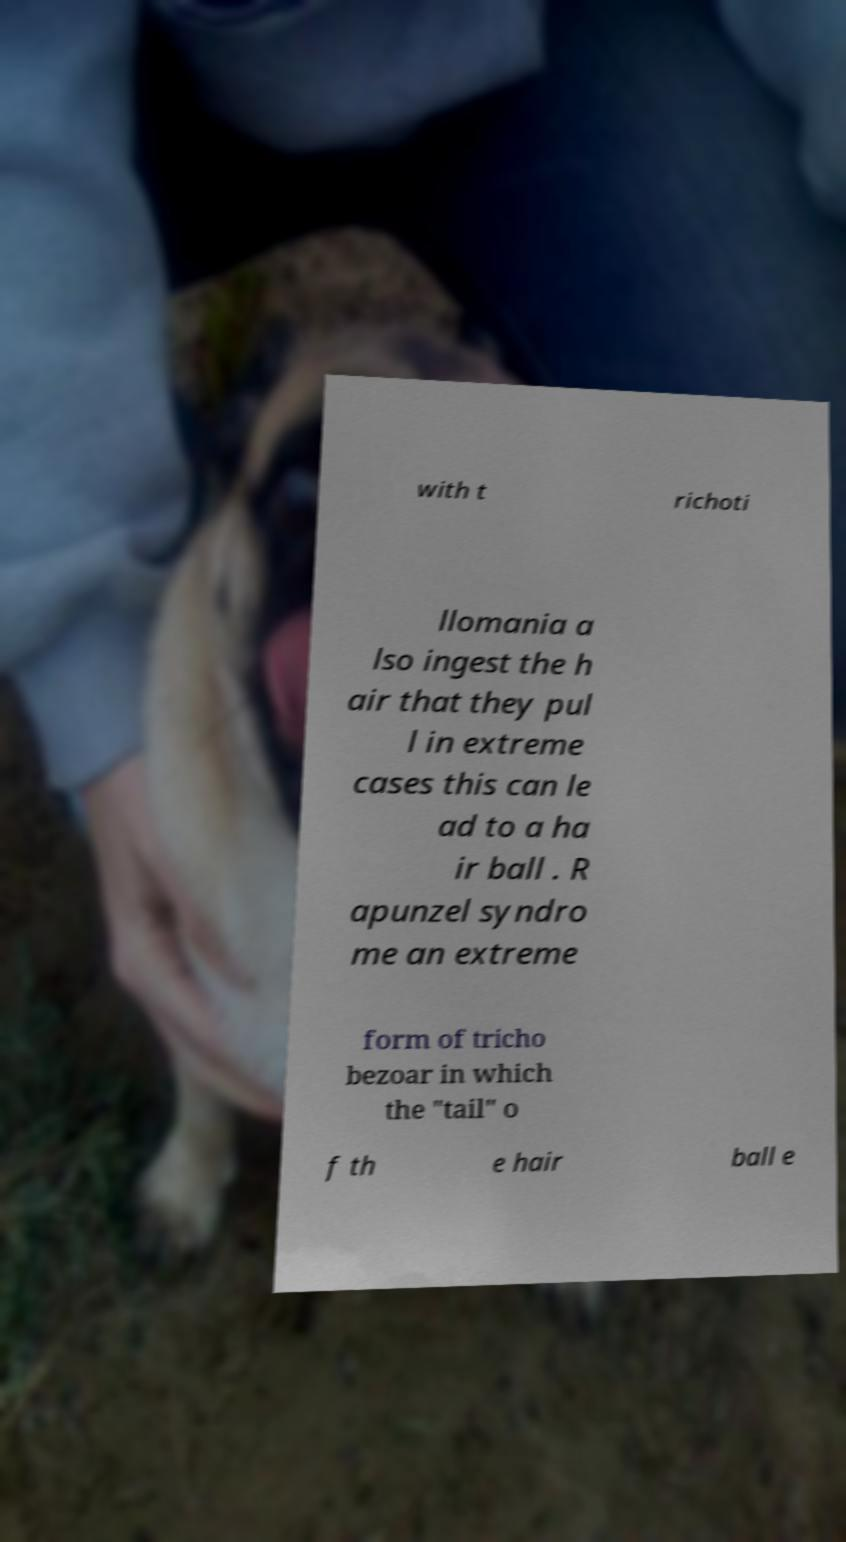There's text embedded in this image that I need extracted. Can you transcribe it verbatim? with t richoti llomania a lso ingest the h air that they pul l in extreme cases this can le ad to a ha ir ball . R apunzel syndro me an extreme form of tricho bezoar in which the "tail" o f th e hair ball e 